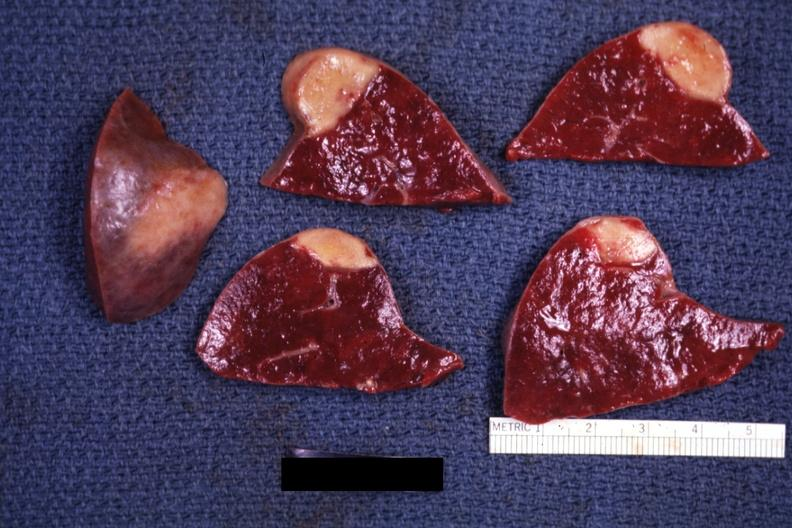what is present?
Answer the question using a single word or phrase. Spleen 